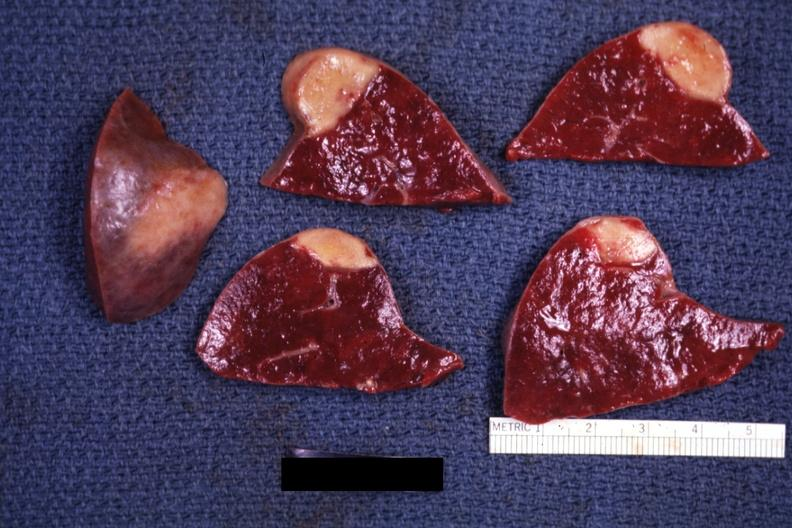what is present?
Answer the question using a single word or phrase. Spleen 